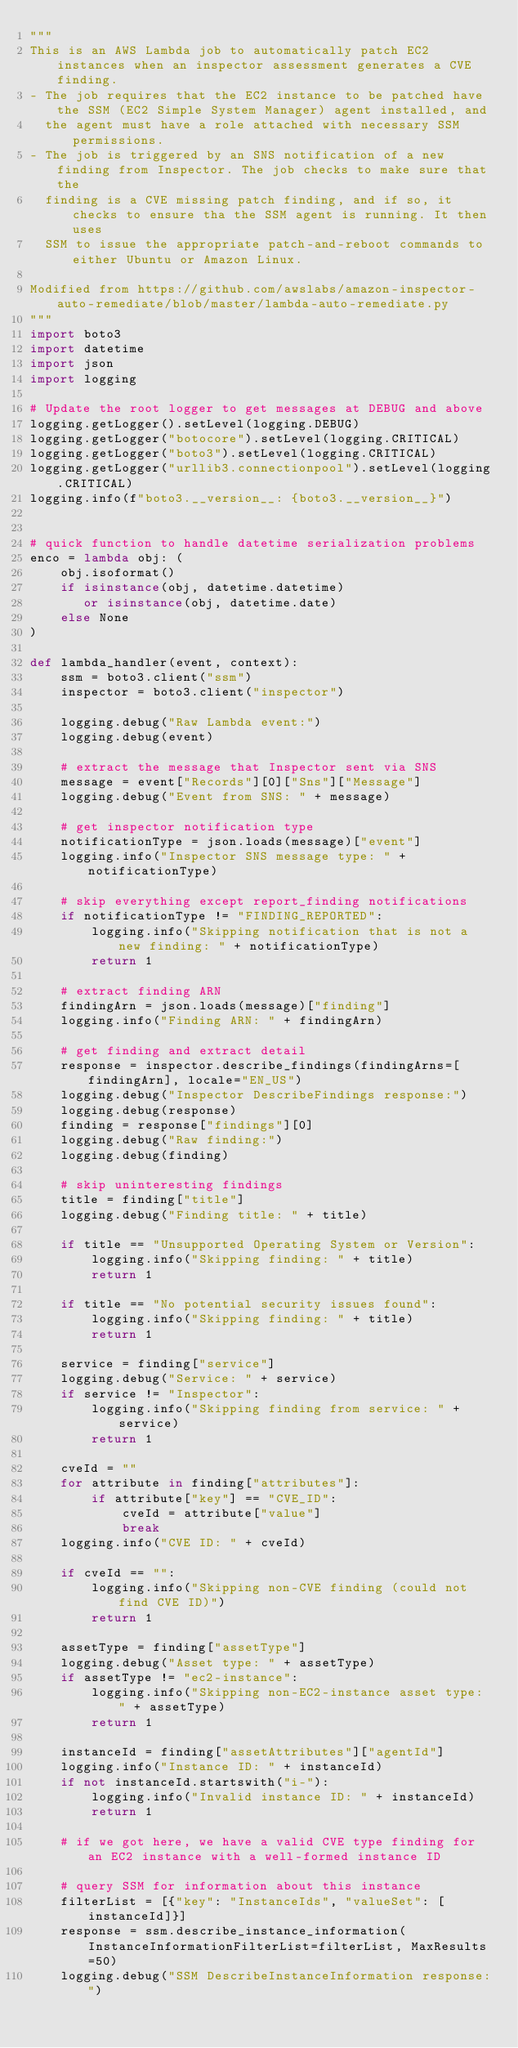<code> <loc_0><loc_0><loc_500><loc_500><_Python_>"""
This is an AWS Lambda job to automatically patch EC2 instances when an inspector assessment generates a CVE finding.
- The job requires that the EC2 instance to be patched have the SSM (EC2 Simple System Manager) agent installed, and
  the agent must have a role attached with necessary SSM permissions.
- The job is triggered by an SNS notification of a new finding from Inspector. The job checks to make sure that the
  finding is a CVE missing patch finding, and if so, it checks to ensure tha the SSM agent is running. It then uses
  SSM to issue the appropriate patch-and-reboot commands to either Ubuntu or Amazon Linux.

Modified from https://github.com/awslabs/amazon-inspector-auto-remediate/blob/master/lambda-auto-remediate.py
"""
import boto3
import datetime
import json
import logging

# Update the root logger to get messages at DEBUG and above
logging.getLogger().setLevel(logging.DEBUG)
logging.getLogger("botocore").setLevel(logging.CRITICAL)
logging.getLogger("boto3").setLevel(logging.CRITICAL)
logging.getLogger("urllib3.connectionpool").setLevel(logging.CRITICAL)
logging.info(f"boto3.__version__: {boto3.__version__}")


# quick function to handle datetime serialization problems
enco = lambda obj: (
    obj.isoformat()
    if isinstance(obj, datetime.datetime)
       or isinstance(obj, datetime.date)
    else None
)

def lambda_handler(event, context):
    ssm = boto3.client("ssm")
    inspector = boto3.client("inspector")
    
    logging.debug("Raw Lambda event:")
    logging.debug(event)
    
    # extract the message that Inspector sent via SNS
    message = event["Records"][0]["Sns"]["Message"]
    logging.debug("Event from SNS: " + message)
    
    # get inspector notification type
    notificationType = json.loads(message)["event"]
    logging.info("Inspector SNS message type: " + notificationType)
    
    # skip everything except report_finding notifications
    if notificationType != "FINDING_REPORTED":
        logging.info("Skipping notification that is not a new finding: " + notificationType)
        return 1
    
    # extract finding ARN
    findingArn = json.loads(message)["finding"]
    logging.info("Finding ARN: " + findingArn)
    
    # get finding and extract detail
    response = inspector.describe_findings(findingArns=[findingArn], locale="EN_US")
    logging.debug("Inspector DescribeFindings response:")
    logging.debug(response)
    finding = response["findings"][0]
    logging.debug("Raw finding:")
    logging.debug(finding)
    
    # skip uninteresting findings
    title = finding["title"]
    logging.debug("Finding title: " + title)
    
    if title == "Unsupported Operating System or Version":
        logging.info("Skipping finding: " + title)
        return 1
    
    if title == "No potential security issues found":
        logging.info("Skipping finding: " + title)
        return 1
    
    service = finding["service"]
    logging.debug("Service: " + service)
    if service != "Inspector":
        logging.info("Skipping finding from service: " + service)
        return 1
    
    cveId = ""
    for attribute in finding["attributes"]:
        if attribute["key"] == "CVE_ID":
            cveId = attribute["value"]
            break
    logging.info("CVE ID: " + cveId)
    
    if cveId == "":
        logging.info("Skipping non-CVE finding (could not find CVE ID)")
        return 1
    
    assetType = finding["assetType"]
    logging.debug("Asset type: " + assetType)
    if assetType != "ec2-instance":
        logging.info("Skipping non-EC2-instance asset type: " + assetType)
        return 1
    
    instanceId = finding["assetAttributes"]["agentId"]
    logging.info("Instance ID: " + instanceId)
    if not instanceId.startswith("i-"):
        logging.info("Invalid instance ID: " + instanceId)
        return 1
    
    # if we got here, we have a valid CVE type finding for an EC2 instance with a well-formed instance ID
    
    # query SSM for information about this instance
    filterList = [{"key": "InstanceIds", "valueSet": [instanceId]}]
    response = ssm.describe_instance_information(InstanceInformationFilterList=filterList, MaxResults=50)
    logging.debug("SSM DescribeInstanceInformation response:")</code> 